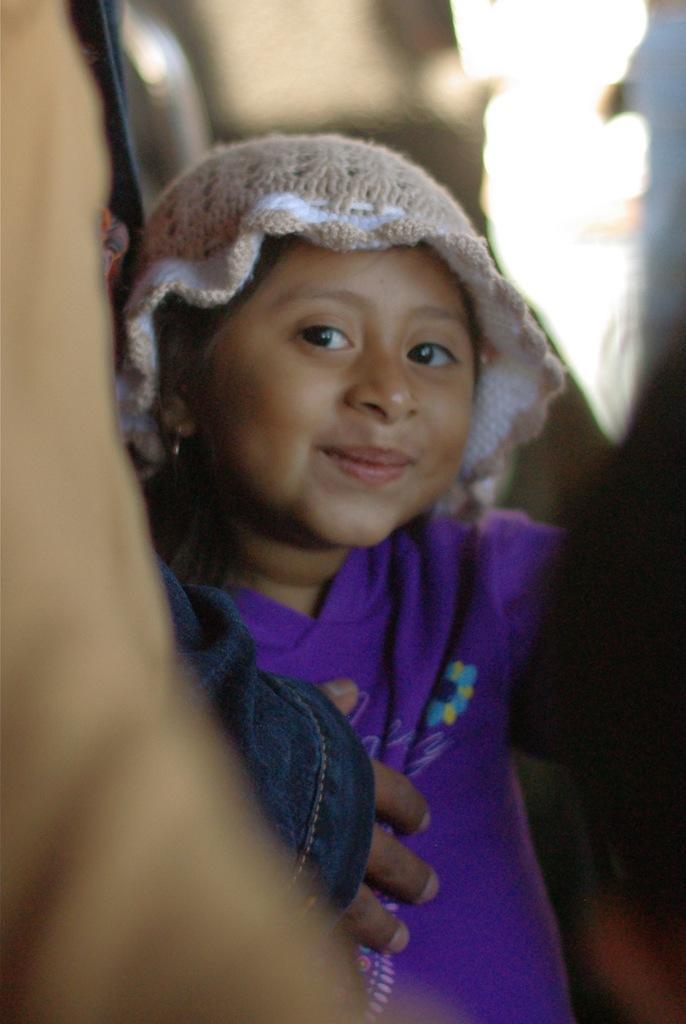Describe this image in one or two sentences. In this picture I can see there is a girl standing and she is smiling and wearing a cap. The backdrop is blurred. 